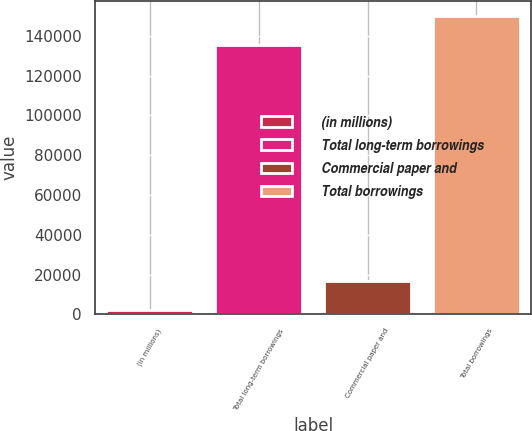<chart> <loc_0><loc_0><loc_500><loc_500><bar_chart><fcel>(in millions)<fcel>Total long-term borrowings<fcel>Commercial paper and<fcel>Total borrowings<nl><fcel>2006<fcel>135316<fcel>16673.3<fcel>149983<nl></chart> 